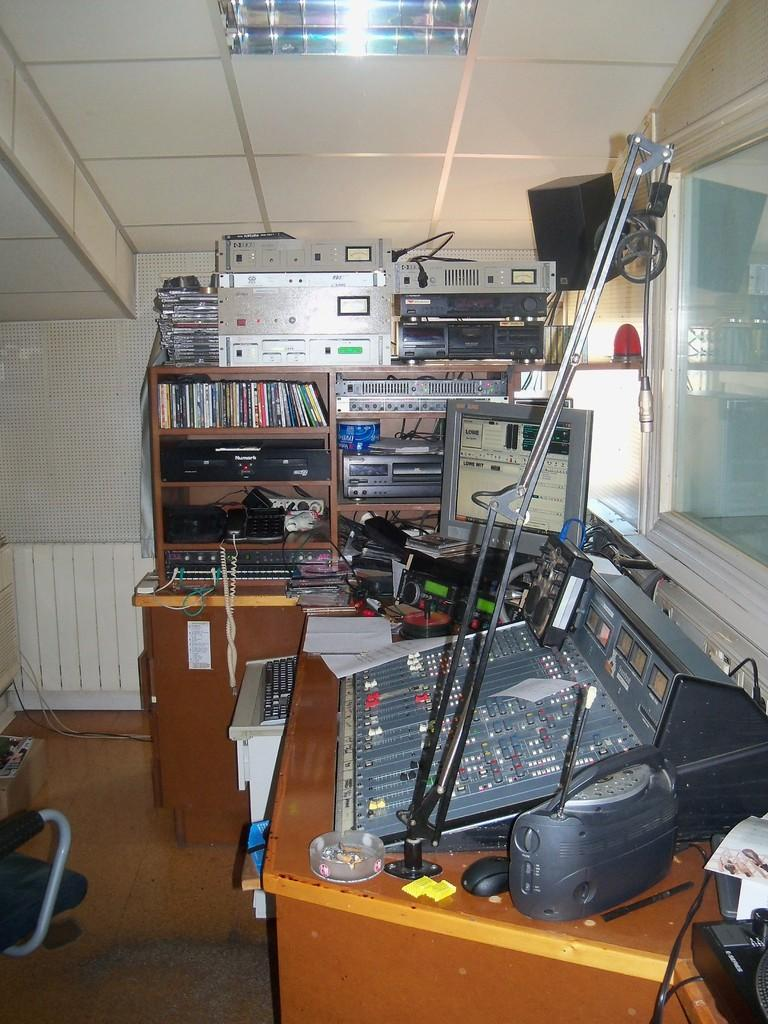What type of furniture can be seen in the image? There are tables in the image. What items are placed on the tables? Electrical instruments, books, and additional electrical items are present on at least one table. What can be seen on the ceiling in the image? There is a light on the ceiling. How many tables are visible in the image? The number of tables cannot be determined from the provided facts. How many knives are being used by the person in the image? There is no person present in the image, and therefore no knives can be observed. What type of headgear is the person wearing in the image? There is no person present in the image, and therefore no headgear can be observed. 